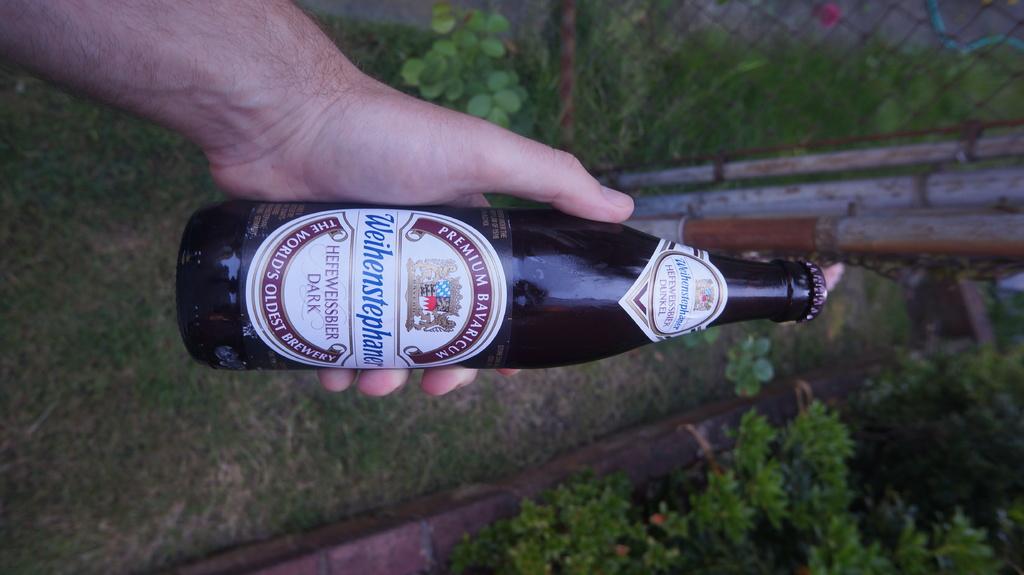What brand is this?
Give a very brief answer. Weihenstephaner. Is this the oldest?
Your answer should be very brief. Yes. 